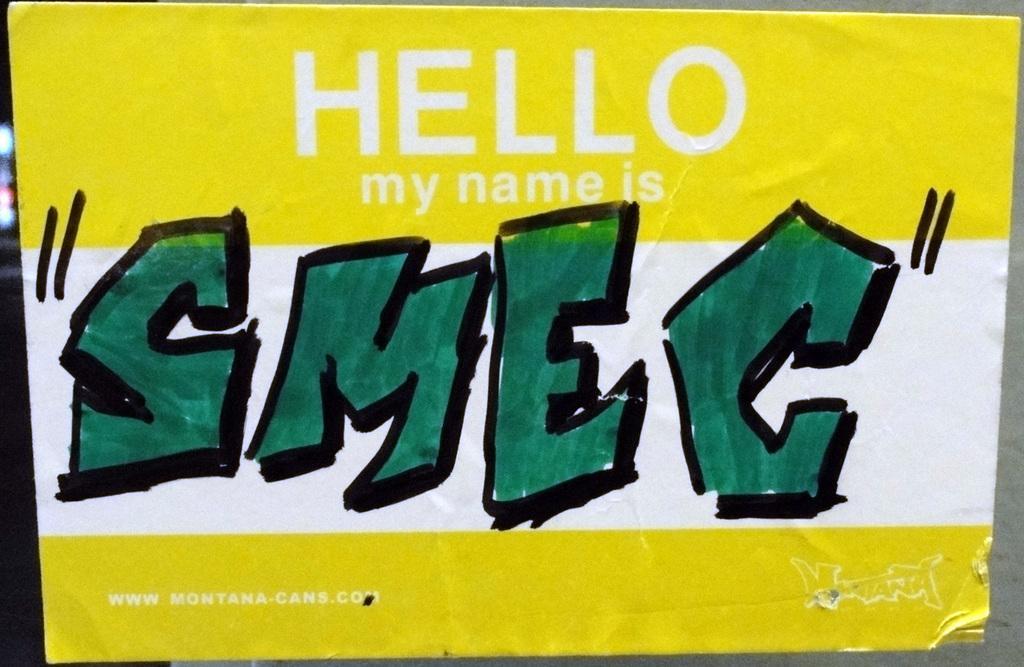How would you summarize this image in a sentence or two? In this picture we can see a board and on the board, it is written something. 